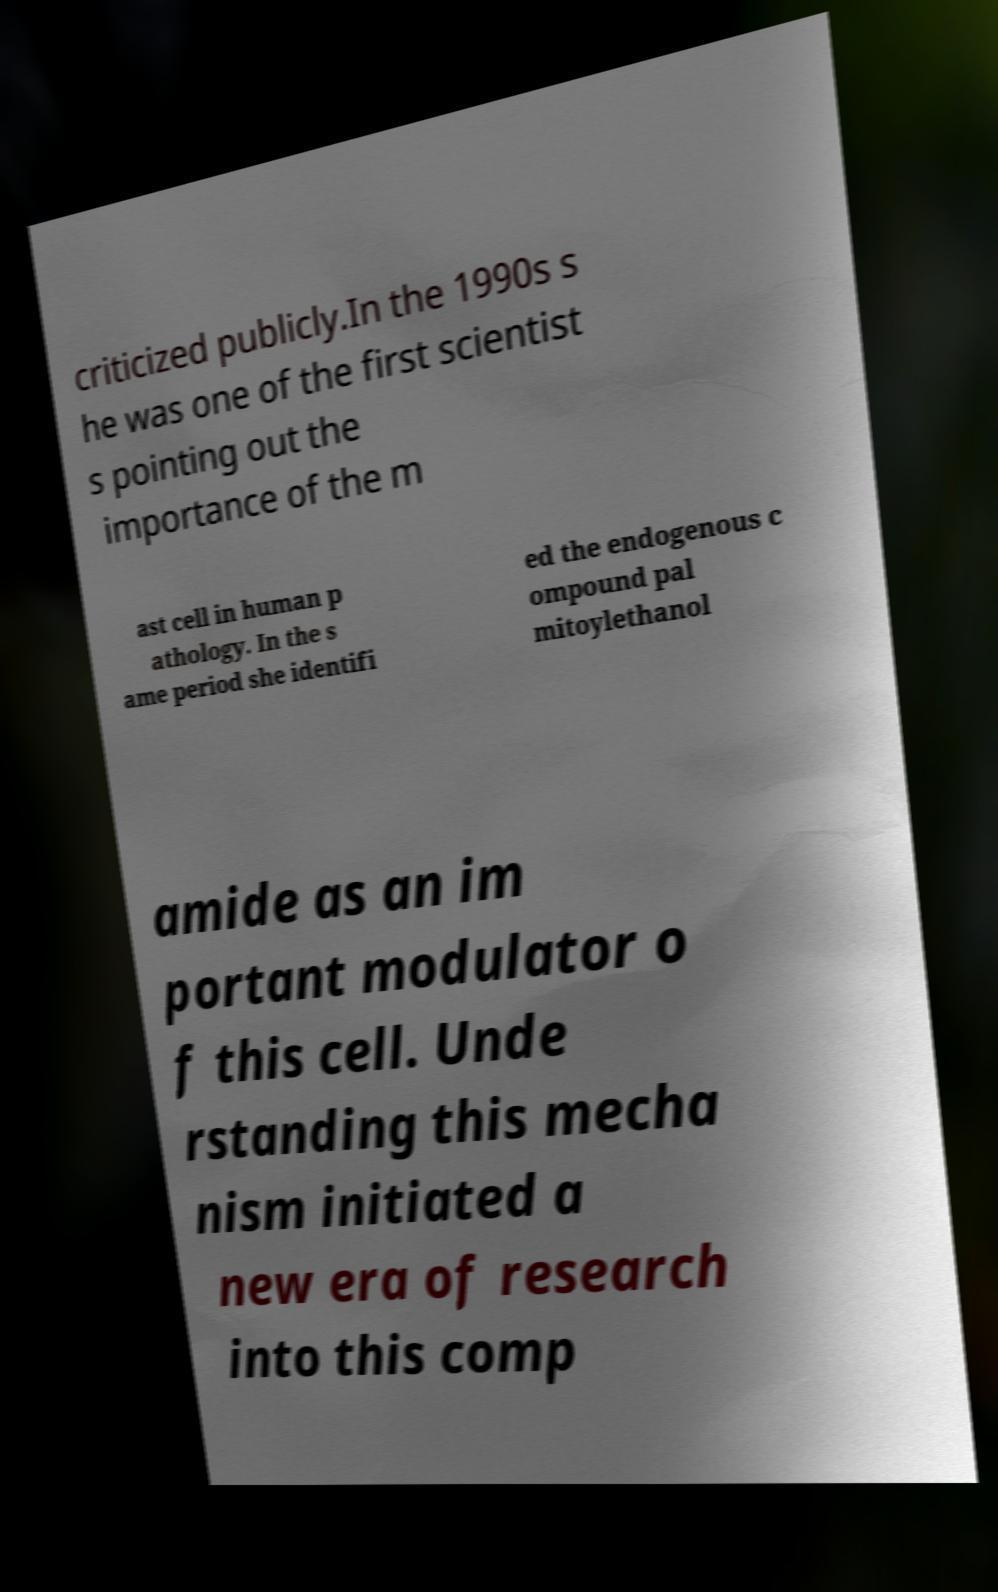Please identify and transcribe the text found in this image. criticized publicly.In the 1990s s he was one of the first scientist s pointing out the importance of the m ast cell in human p athology. In the s ame period she identifi ed the endogenous c ompound pal mitoylethanol amide as an im portant modulator o f this cell. Unde rstanding this mecha nism initiated a new era of research into this comp 